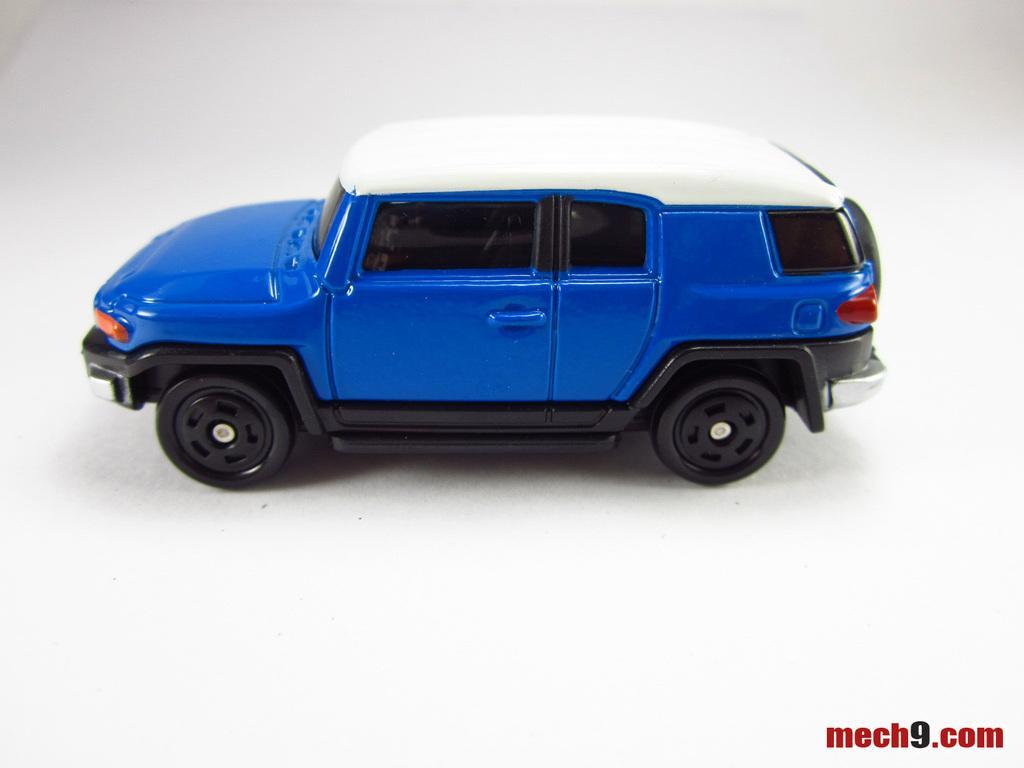In one or two sentences, can you explain what this image depicts? In the center of the image we can see one toy car, which is in blue, white and black color. In the bottom right side of the image we can see some text. 